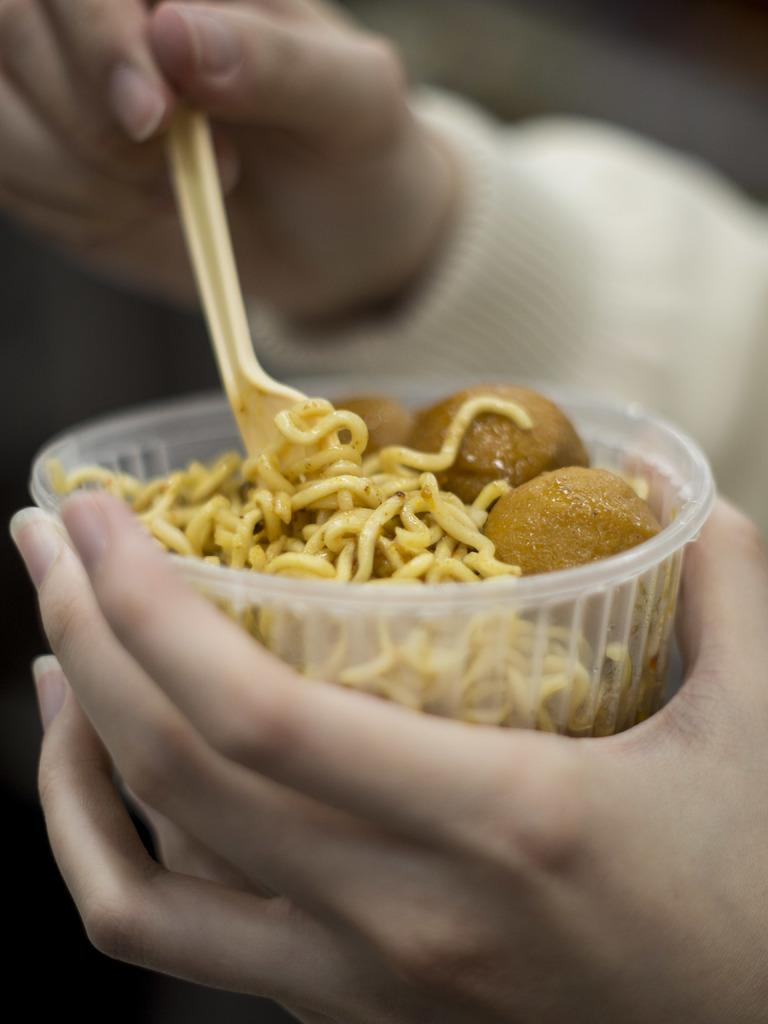What can be seen in the image that belongs to a person? There are hands of a person in the image. What is the person holding in the image? The person is holding a plastic box. What utensil is visible in the image? There is a spoon in the image. What is inside the plastic box? There is food in the plastic box. How does the person wash the lock in the image? There is no lock present in the image, so it is not possible to answer that question. 